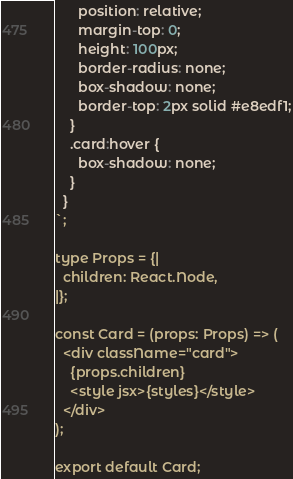<code> <loc_0><loc_0><loc_500><loc_500><_JavaScript_>      position: relative;
      margin-top: 0;
      height: 100px;
      border-radius: none;
      box-shadow: none;
      border-top: 2px solid #e8edf1;
    }
    .card:hover {
      box-shadow: none;
    }
  }
`;

type Props = {|
  children: React.Node,
|};

const Card = (props: Props) => (
  <div className="card">
    {props.children}
    <style jsx>{styles}</style>
  </div>
);

export default Card;
</code> 